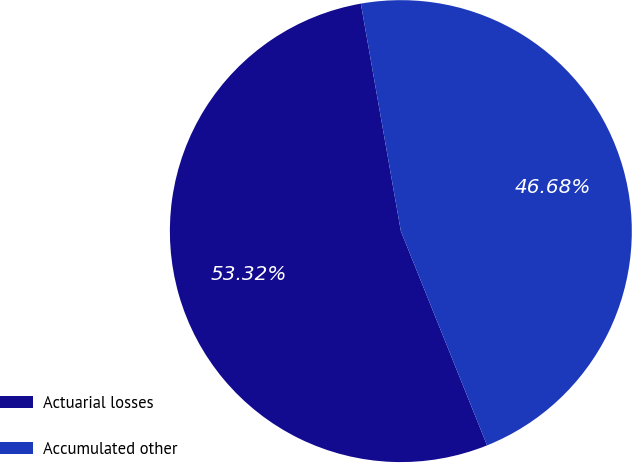Convert chart to OTSL. <chart><loc_0><loc_0><loc_500><loc_500><pie_chart><fcel>Actuarial losses<fcel>Accumulated other<nl><fcel>53.32%<fcel>46.68%<nl></chart> 